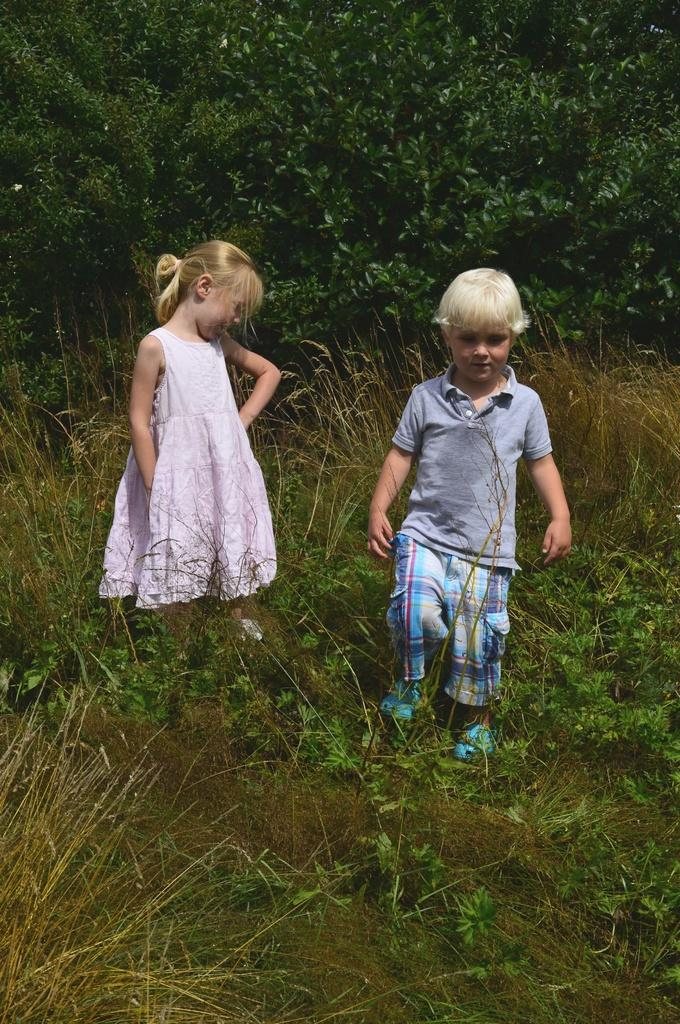How many kids are in the image? There are two kids in the image. Where are the kids located? The kids are on a grassland. What can be seen in the background of the image? There are trees in the background of the image. What type of fish can be heard singing in the image? There are no fish or singing in the image; it features two kids on a grassland with trees in the background. 